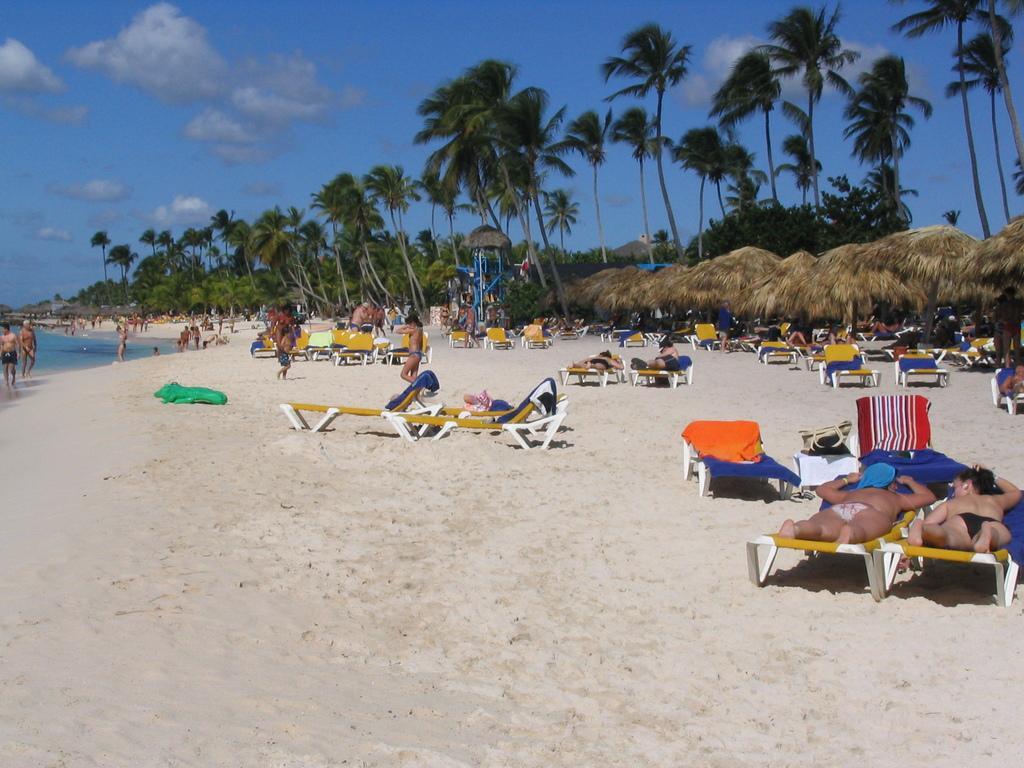Could you give a brief overview of what you see in this image? In this image I can see the beach and few beach beds. I can see few persons sleeping on the beds, few persons standing, few trees which are green in color and the water. In the background I can see the sky. 